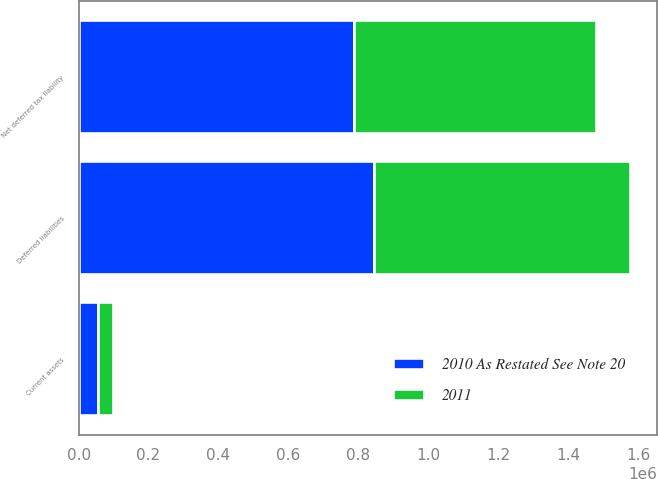Convert chart. <chart><loc_0><loc_0><loc_500><loc_500><stacked_bar_chart><ecel><fcel>Current assets<fcel>Deferred liabilities<fcel>Net deferred tax liability<nl><fcel>2011<fcel>43032<fcel>732528<fcel>689496<nl><fcel>2010 As Restated See Note 20<fcel>54704<fcel>843599<fcel>788895<nl></chart> 